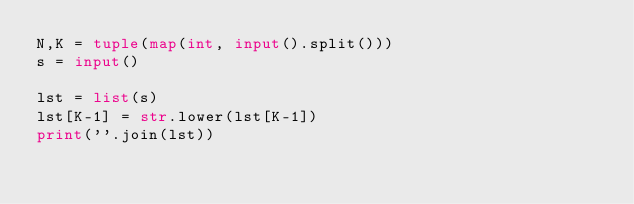<code> <loc_0><loc_0><loc_500><loc_500><_Python_>N,K = tuple(map(int, input().split()))
s = input()

lst = list(s)
lst[K-1] = str.lower(lst[K-1])
print(''.join(lst))
</code> 